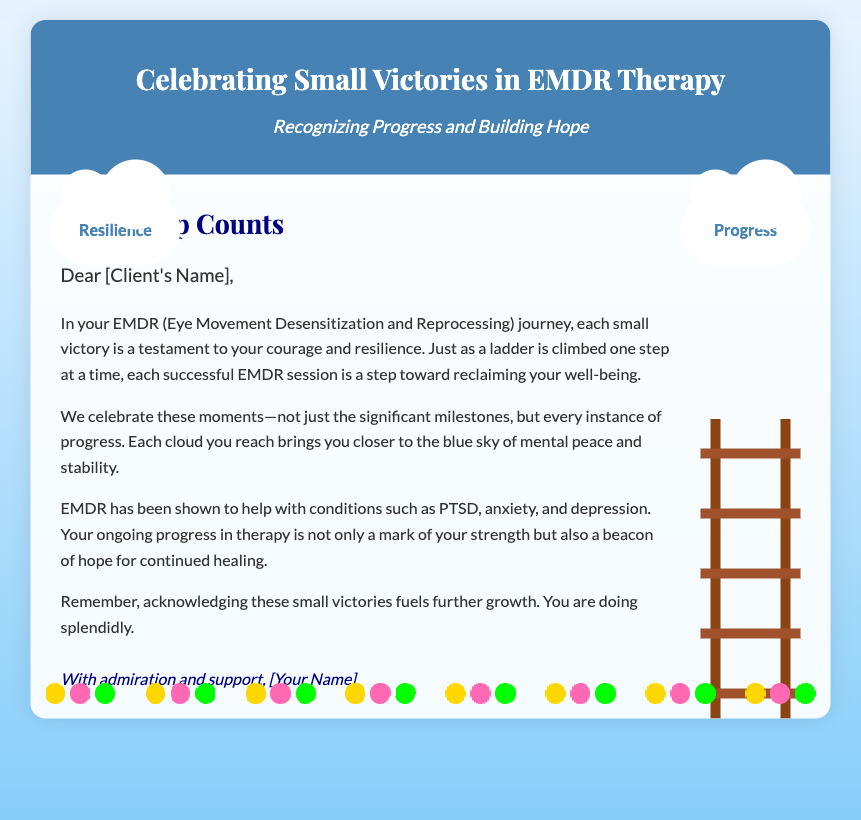What is the title of the card? The title of the card is prominently displayed at the top, "Celebrating Small Victories in EMDR Therapy".
Answer: Celebrating Small Victories in EMDR Therapy What are the two clouds labeled? The clouds represent themes in the content; one is labeled "Progress" and the other "Resilience".
Answer: Progress, Resilience What is the main message header? The main message header is intended to emphasize the overall theme of the card, which is stated as "Every Step Counts".
Answer: Every Step Counts Which therapy does the card focus on? The content specifically mentions EMDR (Eye Movement Desensitization and Reprocessing) therapy.
Answer: EMDR What are three conditions mentioned that EMDR helps with? The document lists PTSD, anxiety, and depression as conditions that EMDR treatment addresses.
Answer: PTSD, anxiety, depression Whose name should be inserted in the greeting? The card is personalized and includes a placeholder for the client’s name, making it feel individualized.
Answer: [Client's Name] What should the sign-off include? The closing statement expresses support and admiration, with a placeholder for the therapist's name.
Answer: [Your Name] What design element represents progress? The document features a ladder as a visual symbol, representing the concept of climbing towards improvement.
Answer: Ladder What color is the header of the card? The header background is described as blue, specifically a shade termed "4682B4".
Answer: Blue 